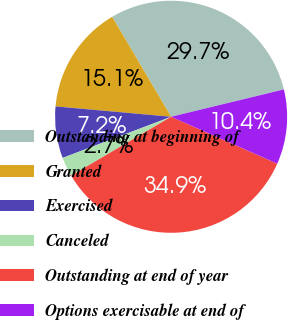<chart> <loc_0><loc_0><loc_500><loc_500><pie_chart><fcel>Outstanding at beginning of<fcel>Granted<fcel>Exercised<fcel>Canceled<fcel>Outstanding at end of year<fcel>Options exercisable at end of<nl><fcel>29.7%<fcel>15.1%<fcel>7.19%<fcel>2.7%<fcel>34.91%<fcel>10.41%<nl></chart> 